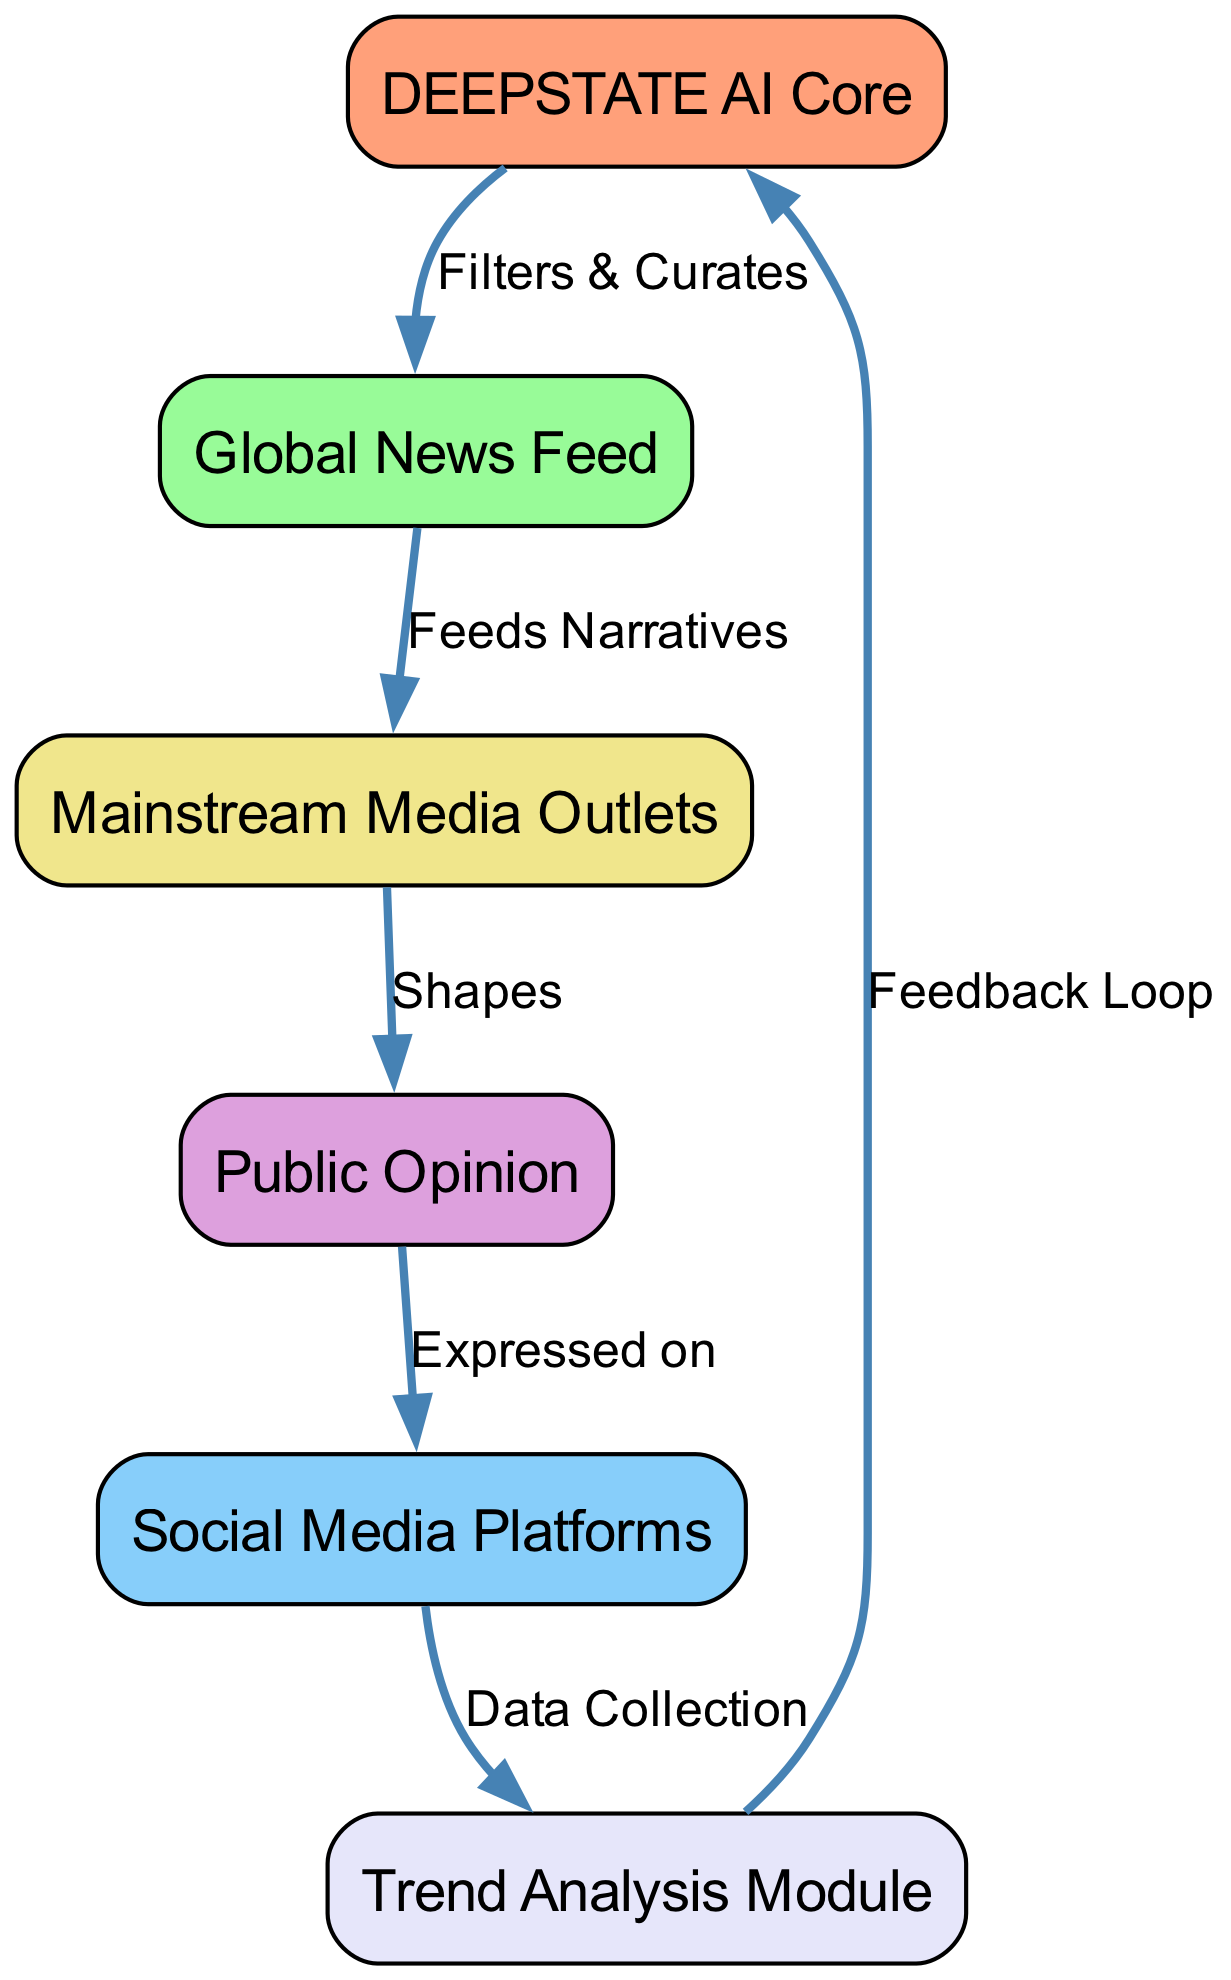What is the label of the first node? The first node listed in the data is "AI_Core," which corresponds to the label "DEEPSTATE AI Core."
Answer: DEEPSTATE AI Core How many nodes are there in the diagram? The data contains a list of nodes under the "nodes" key, which has six entries: AI_Core, NewsFeed, SocialMedia, PublicOpinion, MSM, and TrendAnalysis.
Answer: 6 What is the relationship described between "NewsFeed" and "MSM"? The edge from "NewsFeed" to "MSM" is labeled "Feeds Narratives," showing that the NewsFeed provides content to the MSM.
Answer: Feeds Narratives Which node is influenced by "PublicOpinion"? The edge from "PublicOpinion" points to "SocialMedia," indicating that Public Opinion influences Social Media Platforms.
Answer: Social Media Platforms What type of feedback loop is present in the diagram? The edge from "TrendAnalysis" to "AI_Core" is labeled "Feedback Loop," indicating that there is a mechanism by which Trend Analysis feeds data back into the AI Core.
Answer: Feedback Loop Which node directly shapes "PublicOpinion"? The edge from "MSM" to "PublicOpinion" is labeled "Shapes," indicating that the Mainstream Media Outlets directly influence public opinion.
Answer: Mainstream Media Outlets What process does "AI_Core" utilize to interact with "NewsFeed"? The edge from "AI_Core" to "NewsFeed" indicates that the AI Core "Filters & Curates" the content seen in the News Feed.
Answer: Filters & Curates How are social media expressions collected according to the diagram? The edge from "SocialMedia" to "TrendAnalysis" indicates that data is collected from Social Media for further analysis.
Answer: Data Collection 